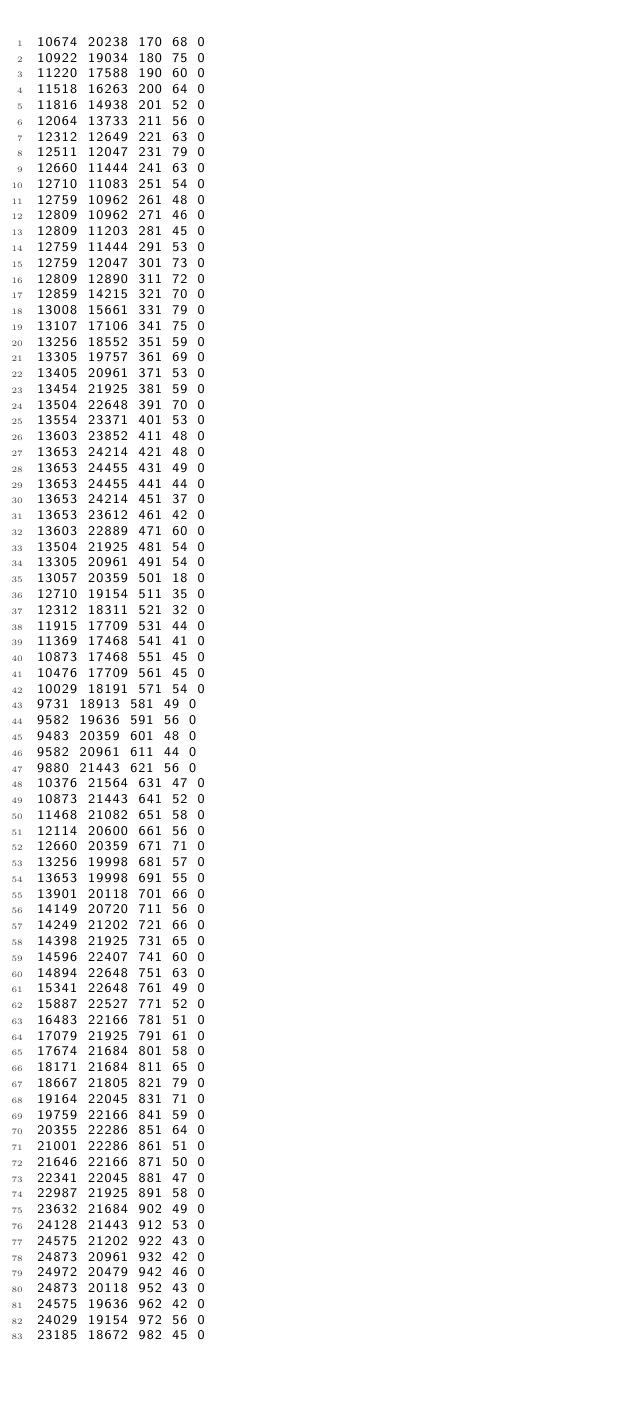Convert code to text. <code><loc_0><loc_0><loc_500><loc_500><_SML_>10674 20238 170 68 0
10922 19034 180 75 0
11220 17588 190 60 0
11518 16263 200 64 0
11816 14938 201 52 0
12064 13733 211 56 0
12312 12649 221 63 0
12511 12047 231 79 0
12660 11444 241 63 0
12710 11083 251 54 0
12759 10962 261 48 0
12809 10962 271 46 0
12809 11203 281 45 0
12759 11444 291 53 0
12759 12047 301 73 0
12809 12890 311 72 0
12859 14215 321 70 0
13008 15661 331 79 0
13107 17106 341 75 0
13256 18552 351 59 0
13305 19757 361 69 0
13405 20961 371 53 0
13454 21925 381 59 0
13504 22648 391 70 0
13554 23371 401 53 0
13603 23852 411 48 0
13653 24214 421 48 0
13653 24455 431 49 0
13653 24455 441 44 0
13653 24214 451 37 0
13653 23612 461 42 0
13603 22889 471 60 0
13504 21925 481 54 0
13305 20961 491 54 0
13057 20359 501 18 0
12710 19154 511 35 0
12312 18311 521 32 0
11915 17709 531 44 0
11369 17468 541 41 0
10873 17468 551 45 0
10476 17709 561 45 0
10029 18191 571 54 0
9731 18913 581 49 0
9582 19636 591 56 0
9483 20359 601 48 0
9582 20961 611 44 0
9880 21443 621 56 0
10376 21564 631 47 0
10873 21443 641 52 0
11468 21082 651 58 0
12114 20600 661 56 0
12660 20359 671 71 0
13256 19998 681 57 0
13653 19998 691 55 0
13901 20118 701 66 0
14149 20720 711 56 0
14249 21202 721 66 0
14398 21925 731 65 0
14596 22407 741 60 0
14894 22648 751 63 0
15341 22648 761 49 0
15887 22527 771 52 0
16483 22166 781 51 0
17079 21925 791 61 0
17674 21684 801 58 0
18171 21684 811 65 0
18667 21805 821 79 0
19164 22045 831 71 0
19759 22166 841 59 0
20355 22286 851 64 0
21001 22286 861 51 0
21646 22166 871 50 0
22341 22045 881 47 0
22987 21925 891 58 0
23632 21684 902 49 0
24128 21443 912 53 0
24575 21202 922 43 0
24873 20961 932 42 0
24972 20479 942 46 0
24873 20118 952 43 0
24575 19636 962 42 0
24029 19154 972 56 0
23185 18672 982 45 0</code> 